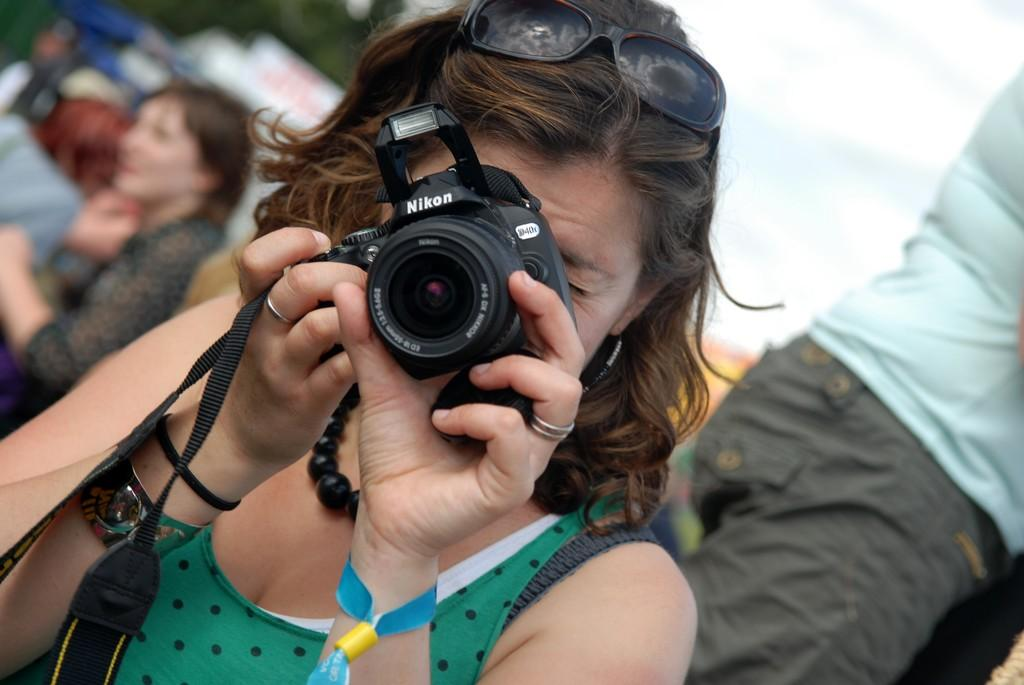Who is the main subject in the image? There is a woman in the image. What is the woman holding in the image? The woman is holding a camera. What can be seen on the woman's head? The woman has shiva spectacles on her head. Can you describe the other people in the image? There is another woman seated in the image and a man standing in the image. What type of clocks can be seen on the queen's head in the image? There is no queen or clocks present in the image. What direction is the woman walking in the image? The image does not show the woman walking; she is holding a camera and standing still. 